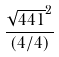<formula> <loc_0><loc_0><loc_500><loc_500>\frac { \sqrt { 4 4 1 } ^ { 2 } } { ( 4 / 4 ) }</formula> 